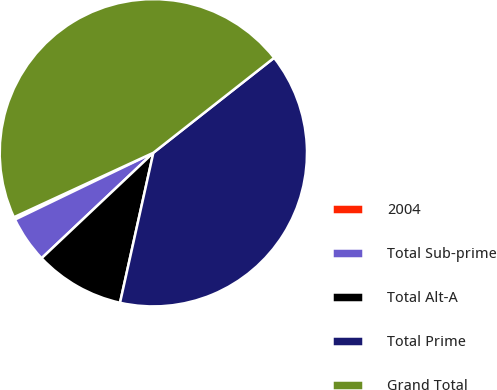<chart> <loc_0><loc_0><loc_500><loc_500><pie_chart><fcel>2004<fcel>Total Sub-prime<fcel>Total Alt-A<fcel>Total Prime<fcel>Grand Total<nl><fcel>0.27%<fcel>4.88%<fcel>9.48%<fcel>39.09%<fcel>46.29%<nl></chart> 